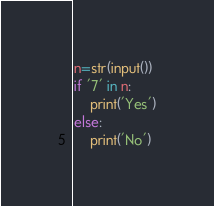Convert code to text. <code><loc_0><loc_0><loc_500><loc_500><_Python_>n=str(input())
if '7' in n:
    print('Yes')
else:
    print('No')</code> 